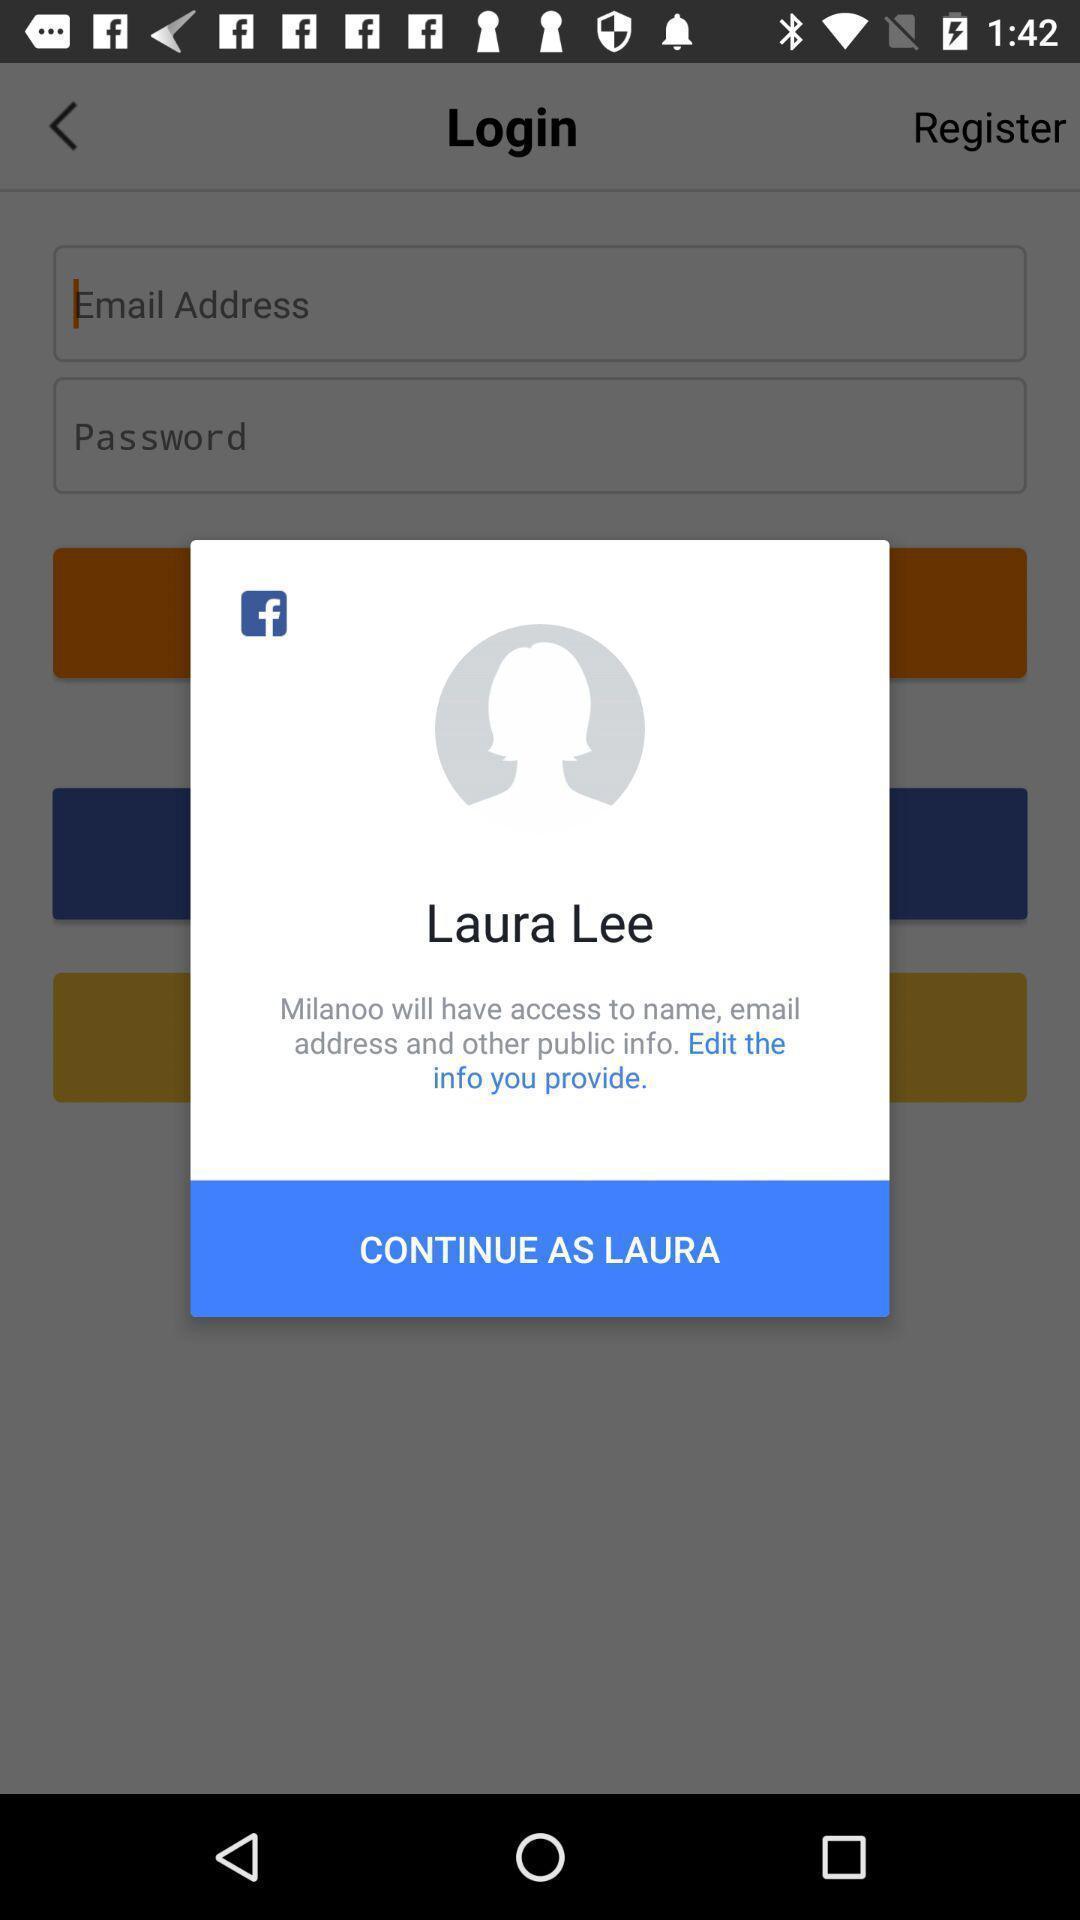Provide a textual representation of this image. Pop-up displaying account to continue. 